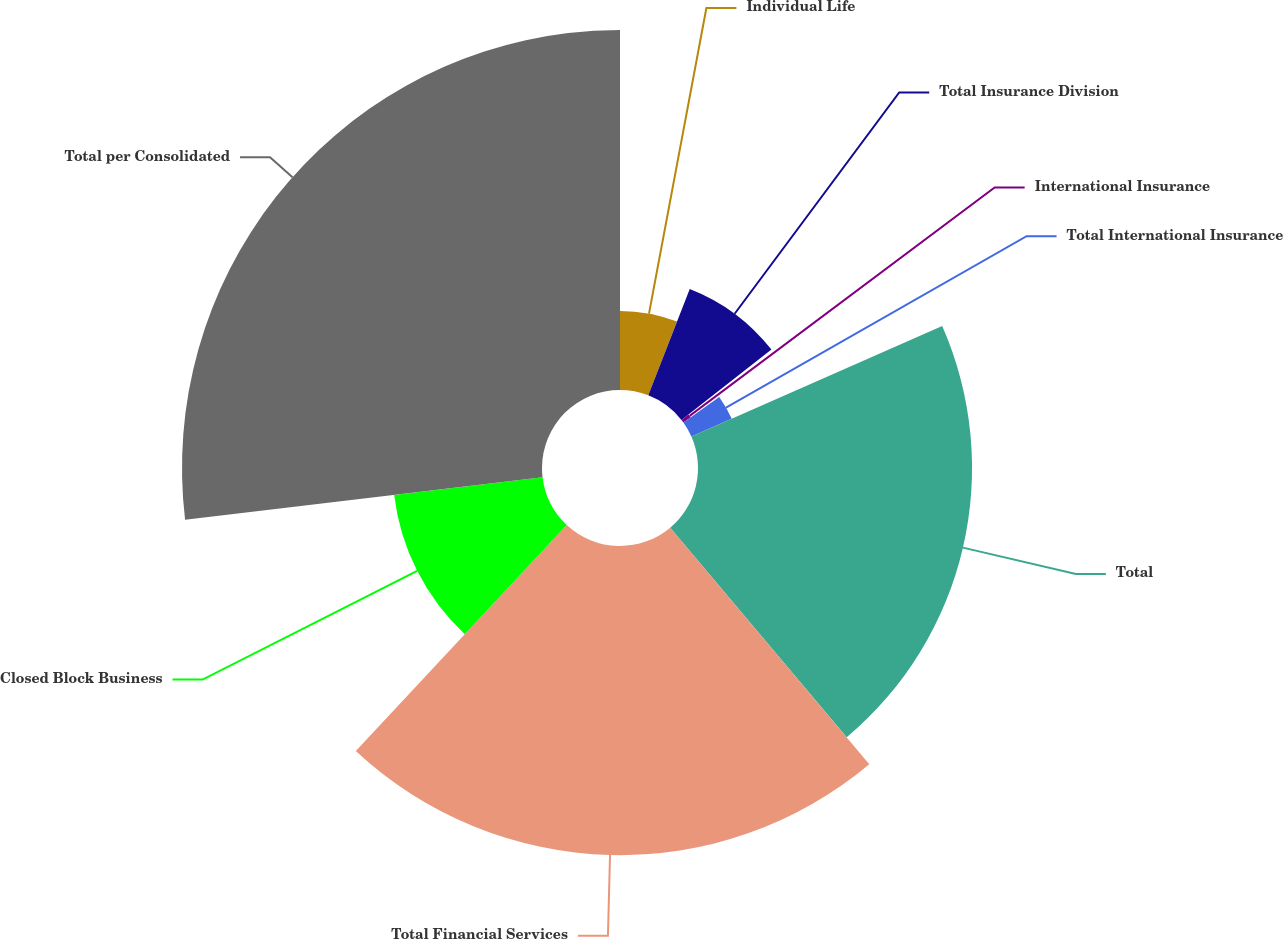Convert chart to OTSL. <chart><loc_0><loc_0><loc_500><loc_500><pie_chart><fcel>Individual Life<fcel>Total Insurance Division<fcel>International Insurance<fcel>Total International Insurance<fcel>Total<fcel>Total Financial Services<fcel>Closed Block Business<fcel>Total per Consolidated<nl><fcel>5.91%<fcel>8.53%<fcel>0.67%<fcel>3.29%<fcel>20.47%<fcel>23.09%<fcel>11.16%<fcel>26.89%<nl></chart> 